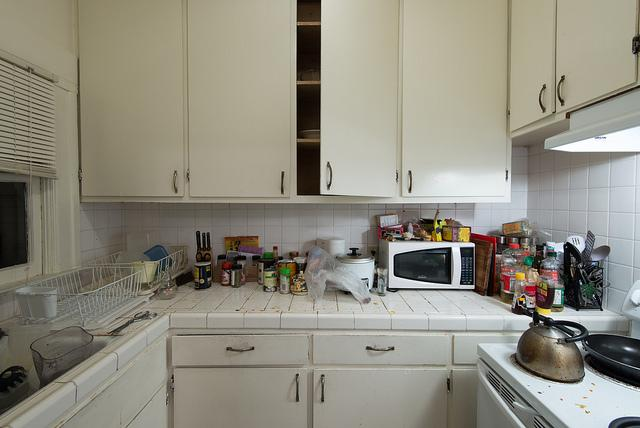What are the two rectangular baskets on the left counter for? Please explain your reasoning. dish draining. You can see dishes in the basket next to the sink. typically you put dishes in there to dry. 